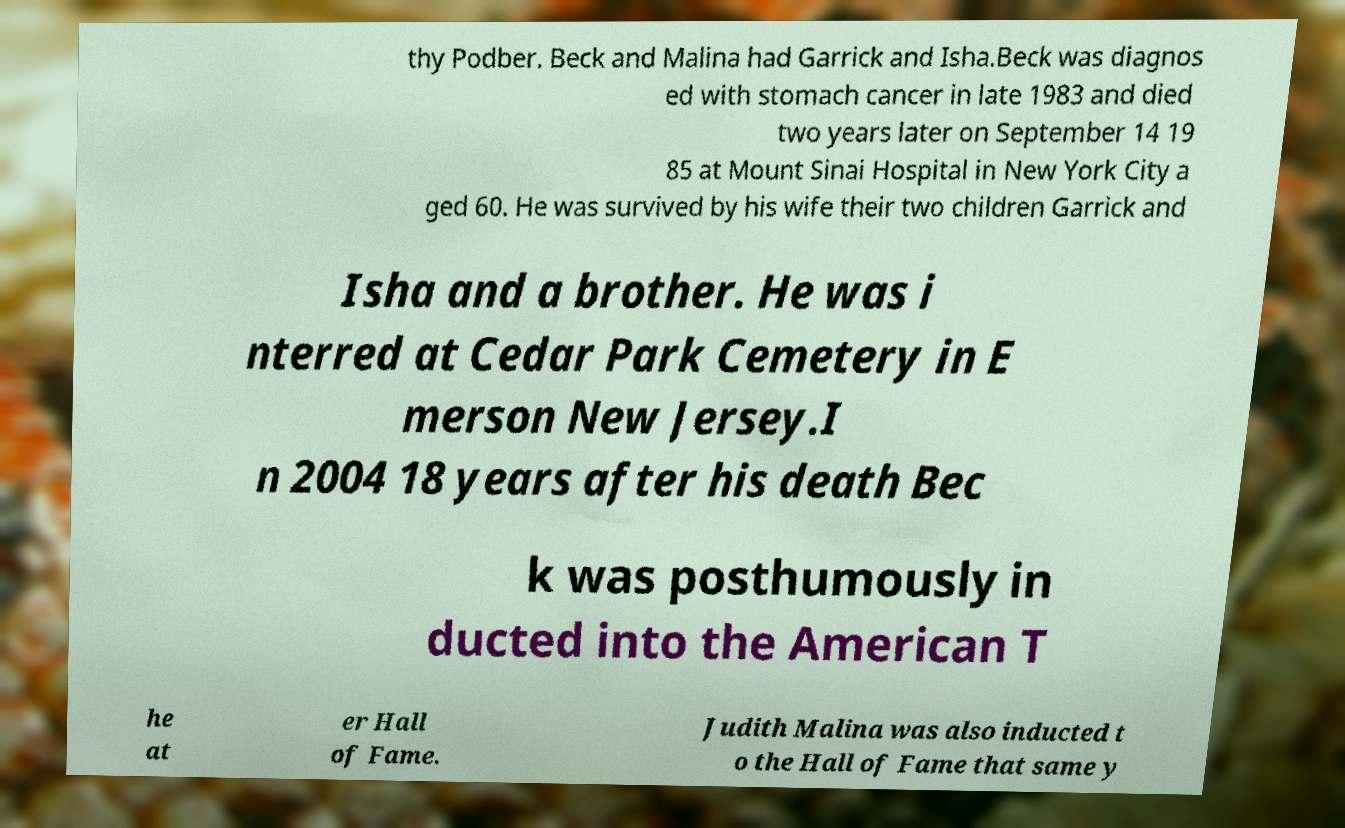Can you provide more context or a brief biography of Beck or Malina? Beck and Judith Malina were prominent figures in the world of theater. Beck, a theater director, and Malina, an actress and director, co-founded The Living Theatre, a highly influential experimental theater company. Their work often addressed controversial themes like pacifism and anarchism, challenging traditional narratives and forms in the performing arts. Their legacy includes inspiring avant-garde theater worldwide. 